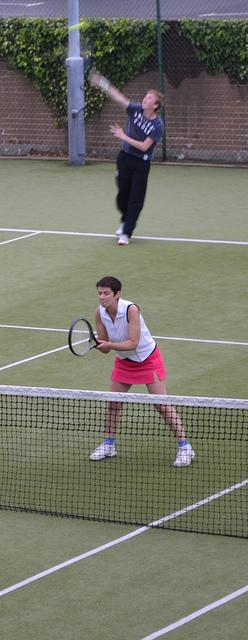What type of tennis are these two players playing? doubles 